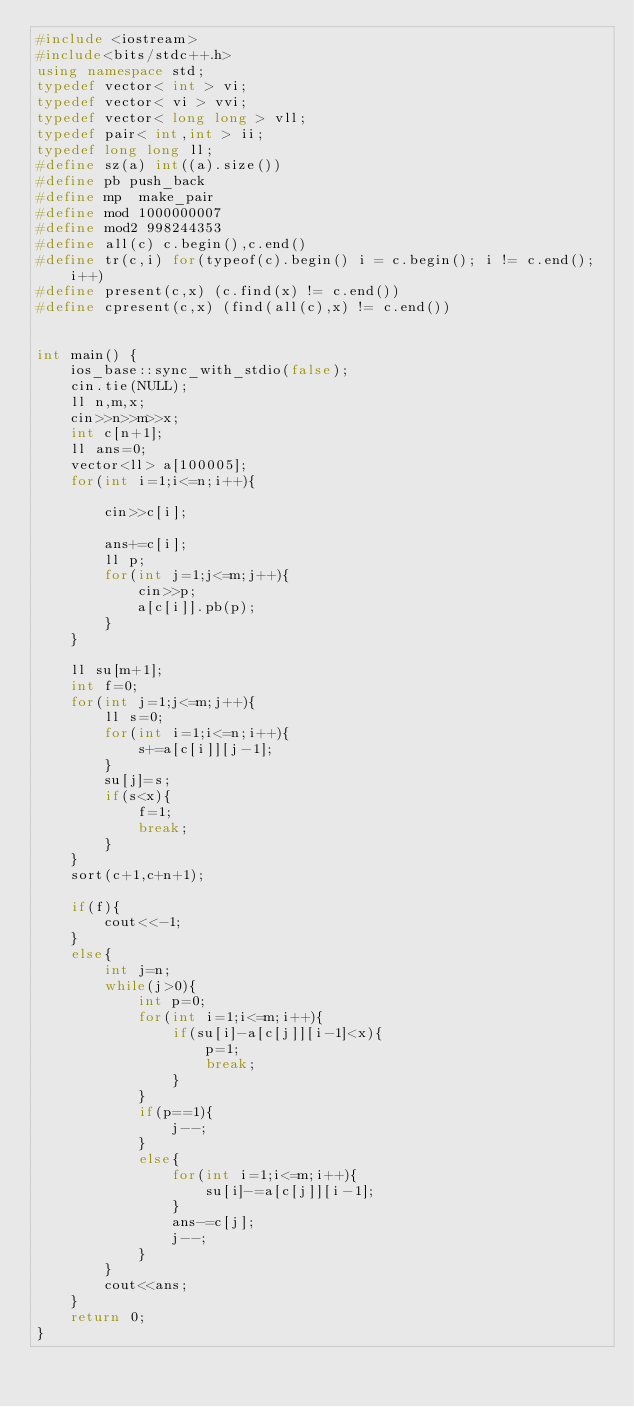Convert code to text. <code><loc_0><loc_0><loc_500><loc_500><_C++_>#include <iostream>
#include<bits/stdc++.h>
using namespace std;
typedef vector< int > vi;
typedef vector< vi > vvi;
typedef vector< long long > vll;
typedef pair< int,int > ii;
typedef long long ll;
#define sz(a) int((a).size())
#define pb push_back
#define mp  make_pair
#define mod 1000000007
#define mod2 998244353
#define all(c) c.begin(),c.end()
#define tr(c,i) for(typeof(c).begin() i = c.begin(); i != c.end(); i++)
#define present(c,x) (c.find(x) != c.end())
#define cpresent(c,x) (find(all(c),x) != c.end())


int main() {
    ios_base::sync_with_stdio(false);
    cin.tie(NULL);
    ll n,m,x;
    cin>>n>>m>>x;
    int c[n+1];
    ll ans=0;
    vector<ll> a[100005];
    for(int i=1;i<=n;i++){
    
        cin>>c[i];
        
        ans+=c[i];
        ll p;
        for(int j=1;j<=m;j++){
            cin>>p;
            a[c[i]].pb(p);
        }
    }
  
    ll su[m+1];
    int f=0;
    for(int j=1;j<=m;j++){
        ll s=0;
        for(int i=1;i<=n;i++){
            s+=a[c[i]][j-1];
        }
        su[j]=s;
        if(s<x){
            f=1;
            break;
        }
    }
    sort(c+1,c+n+1);
    
    if(f){
        cout<<-1;
    }
    else{
        int j=n;
        while(j>0){
            int p=0;
            for(int i=1;i<=m;i++){
                if(su[i]-a[c[j]][i-1]<x){
                    p=1;
                    break;
                }
            }
            if(p==1){
                j--;
            }
            else{
                for(int i=1;i<=m;i++){
                    su[i]-=a[c[j]][i-1];
                }
                ans-=c[j];
                j--;
            }
        }
        cout<<ans;
    }
	return 0;
}
</code> 